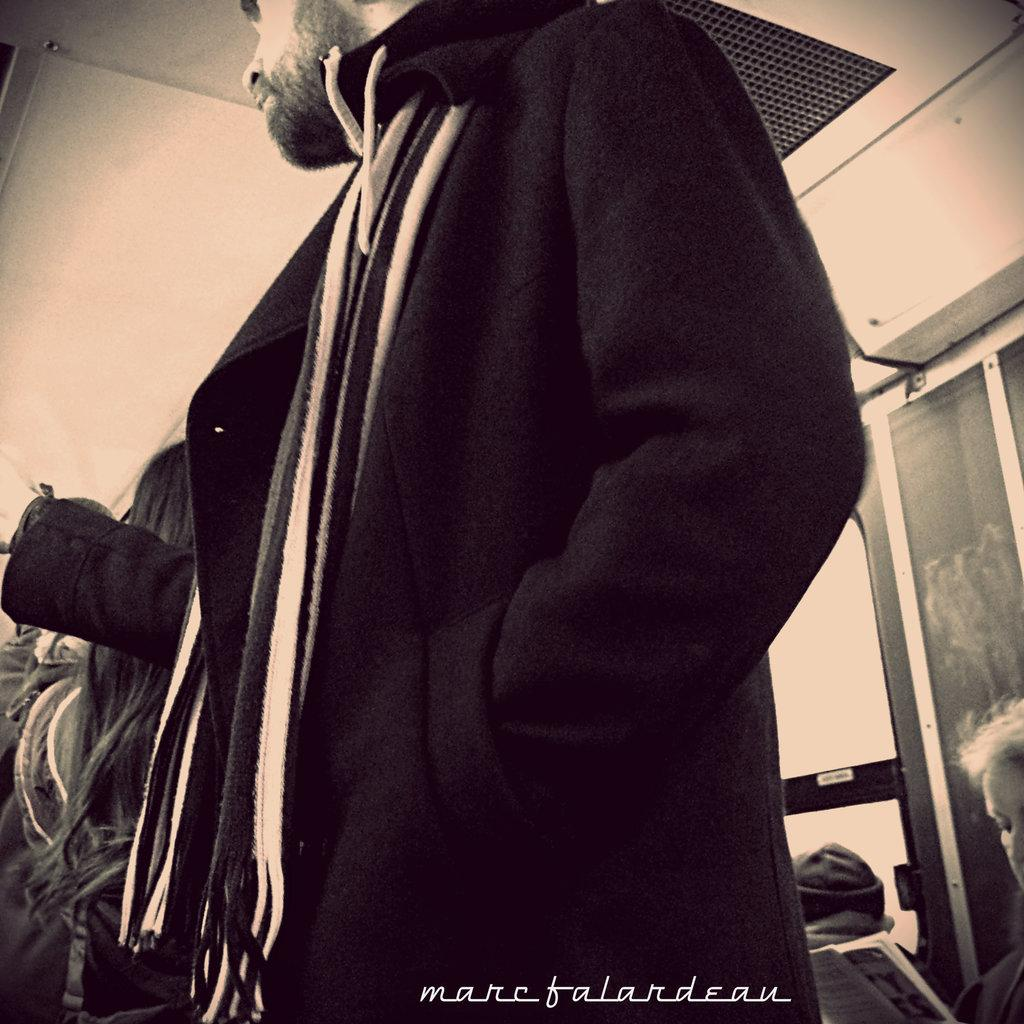How many people are in the image? There are multiple persons in the image. What are the people in the image doing? Some of the persons are standing, while others are sitting. What can be seen on the right side of the image? There is a window on the right side of the image. What is the color of the door in the image? The door in the image is white in color. What type of lipstick is the person wearing in the image? There is no mention of lipstick or any person wearing it in the image. 